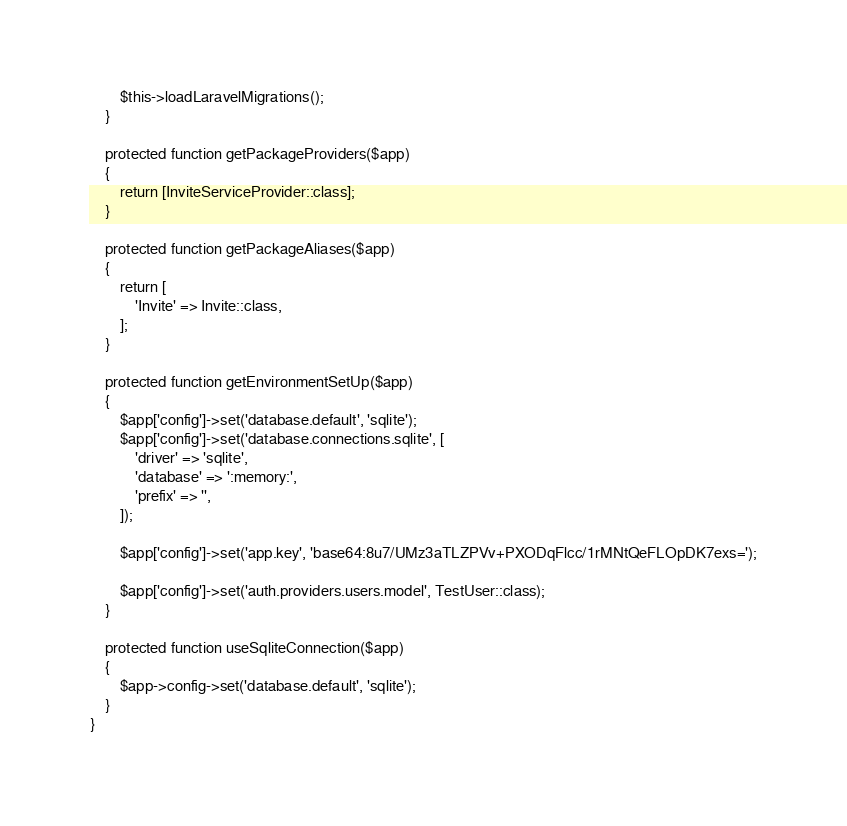<code> <loc_0><loc_0><loc_500><loc_500><_PHP_>        $this->loadLaravelMigrations();
    }

    protected function getPackageProviders($app)
    {
        return [InviteServiceProvider::class];
    }

    protected function getPackageAliases($app)
    {
        return [
            'Invite' => Invite::class,
        ];
    }

    protected function getEnvironmentSetUp($app)
    {
        $app['config']->set('database.default', 'sqlite');
        $app['config']->set('database.connections.sqlite', [
            'driver' => 'sqlite',
            'database' => ':memory:',
            'prefix' => '',
        ]);

        $app['config']->set('app.key', 'base64:8u7/UMz3aTLZPVv+PXODqFlcc/1rMNtQeFLOpDK7exs=');

        $app['config']->set('auth.providers.users.model', TestUser::class);
    }

    protected function useSqliteConnection($app)
    {
        $app->config->set('database.default', 'sqlite');
    }
}
</code> 